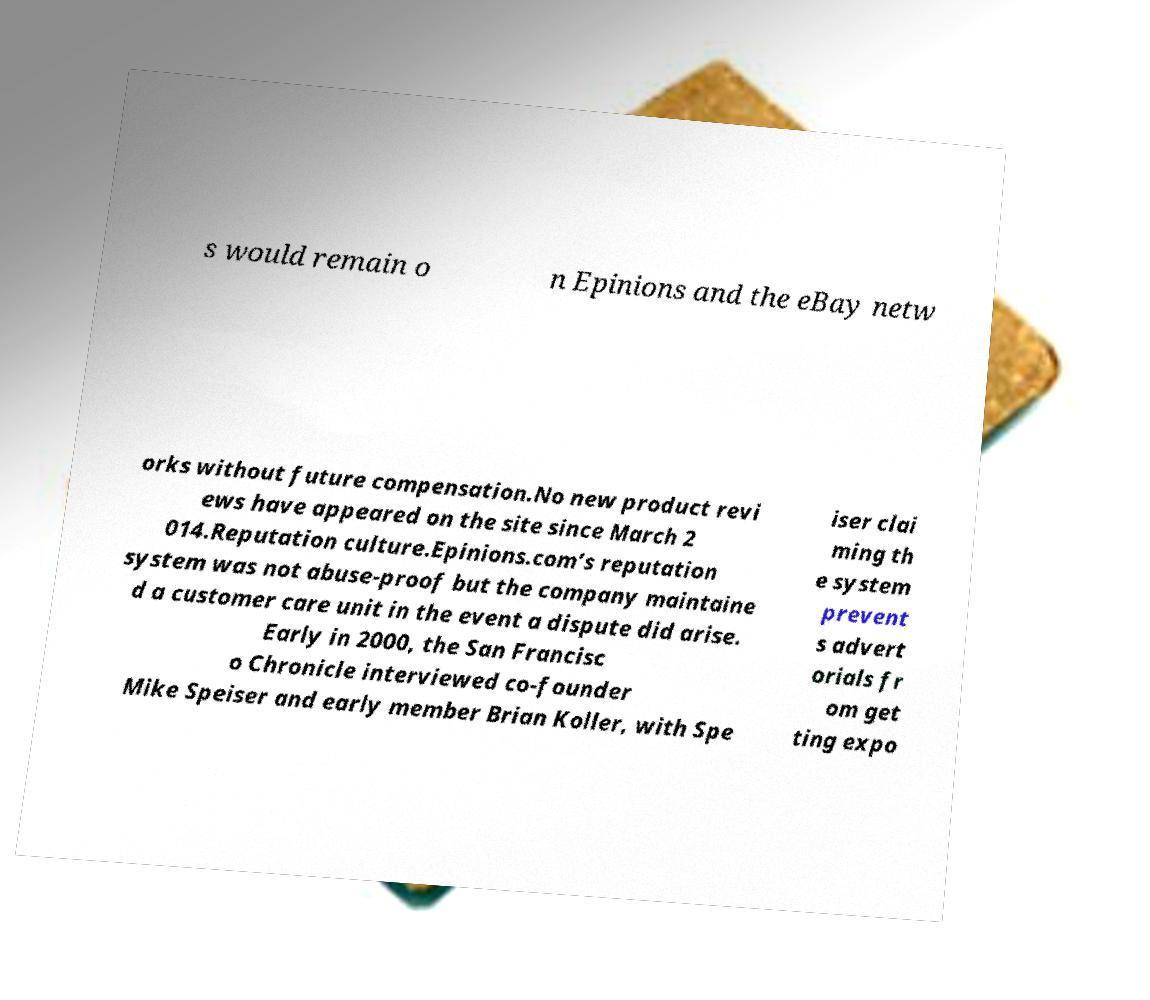Please identify and transcribe the text found in this image. s would remain o n Epinions and the eBay netw orks without future compensation.No new product revi ews have appeared on the site since March 2 014.Reputation culture.Epinions.com’s reputation system was not abuse-proof but the company maintaine d a customer care unit in the event a dispute did arise. Early in 2000, the San Francisc o Chronicle interviewed co-founder Mike Speiser and early member Brian Koller, with Spe iser clai ming th e system prevent s advert orials fr om get ting expo 